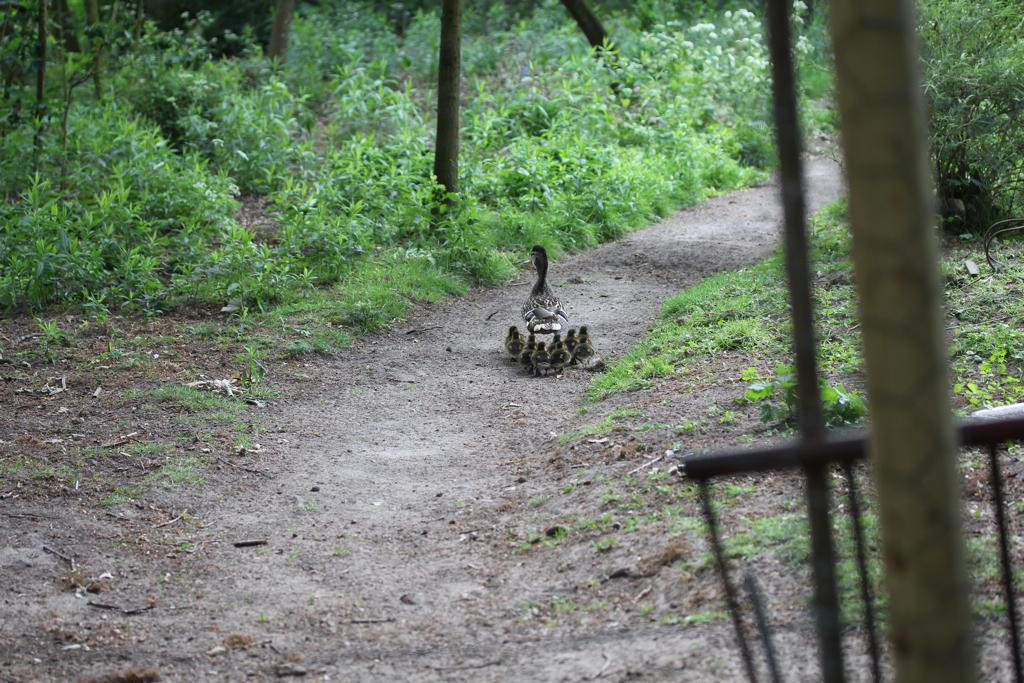What type of living organisms can be seen in the image? Plants and birds are visible in the image. What is the color of the grass in the image? There is green grass in the image. What can be found on the right side of the image? There are metal objects on the right side of the image. What type of cheese is being used by the pig in the image? There is no pig or cheese present in the image. How does the bird sense the presence of the plants in the image? The image does not provide information about the bird's senses or its interaction with the plants. 